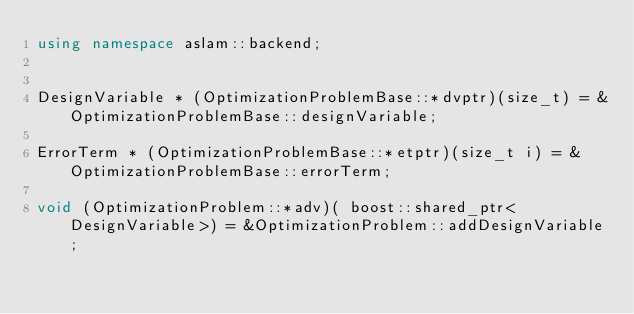<code> <loc_0><loc_0><loc_500><loc_500><_C++_>using namespace aslam::backend;


DesignVariable * (OptimizationProblemBase::*dvptr)(size_t) = &OptimizationProblemBase::designVariable;

ErrorTerm * (OptimizationProblemBase::*etptr)(size_t i) = &OptimizationProblemBase::errorTerm;

void (OptimizationProblem::*adv)( boost::shared_ptr<DesignVariable>) = &OptimizationProblem::addDesignVariable;
</code> 